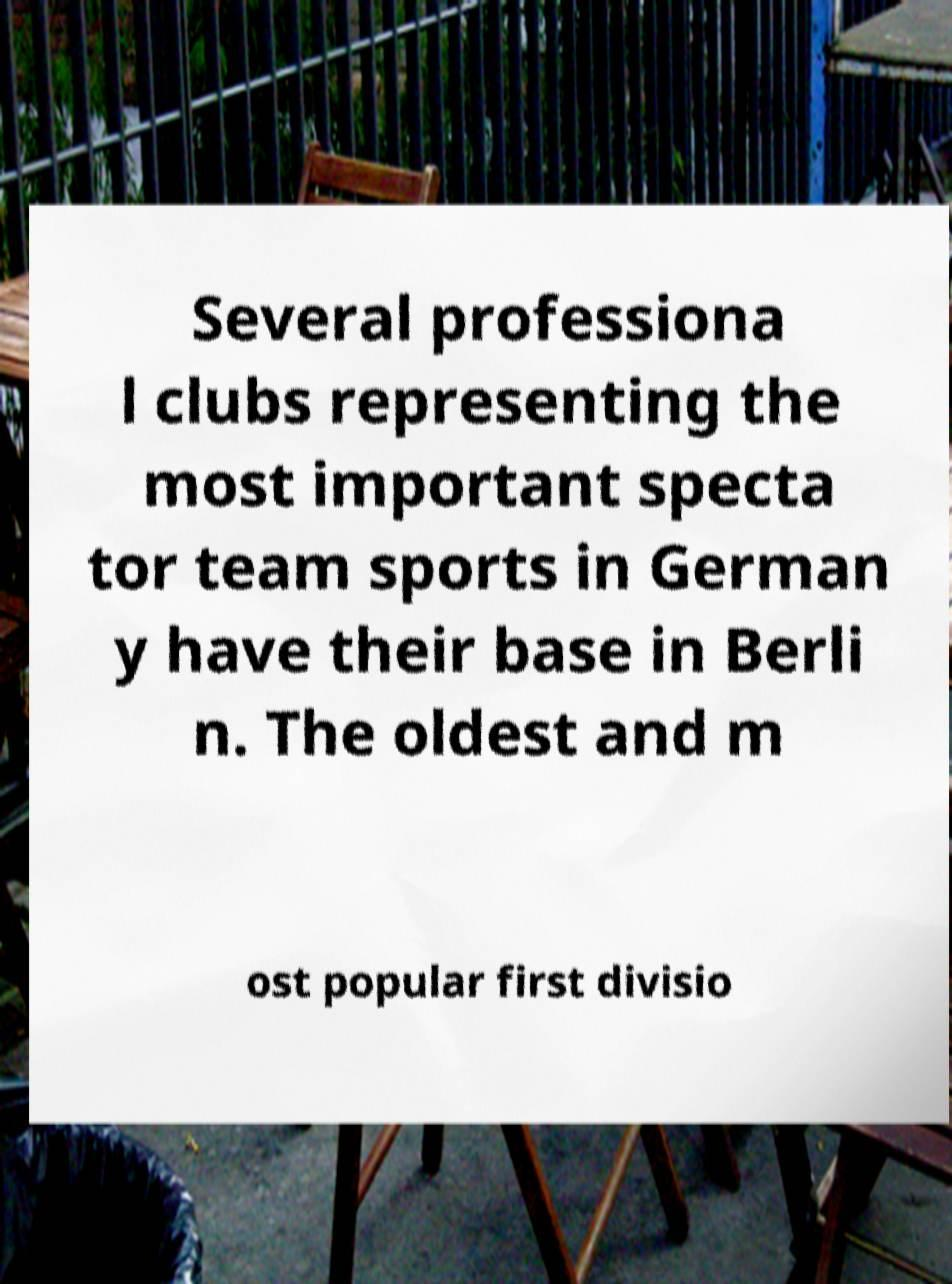Can you read and provide the text displayed in the image?This photo seems to have some interesting text. Can you extract and type it out for me? Several professiona l clubs representing the most important specta tor team sports in German y have their base in Berli n. The oldest and m ost popular first divisio 